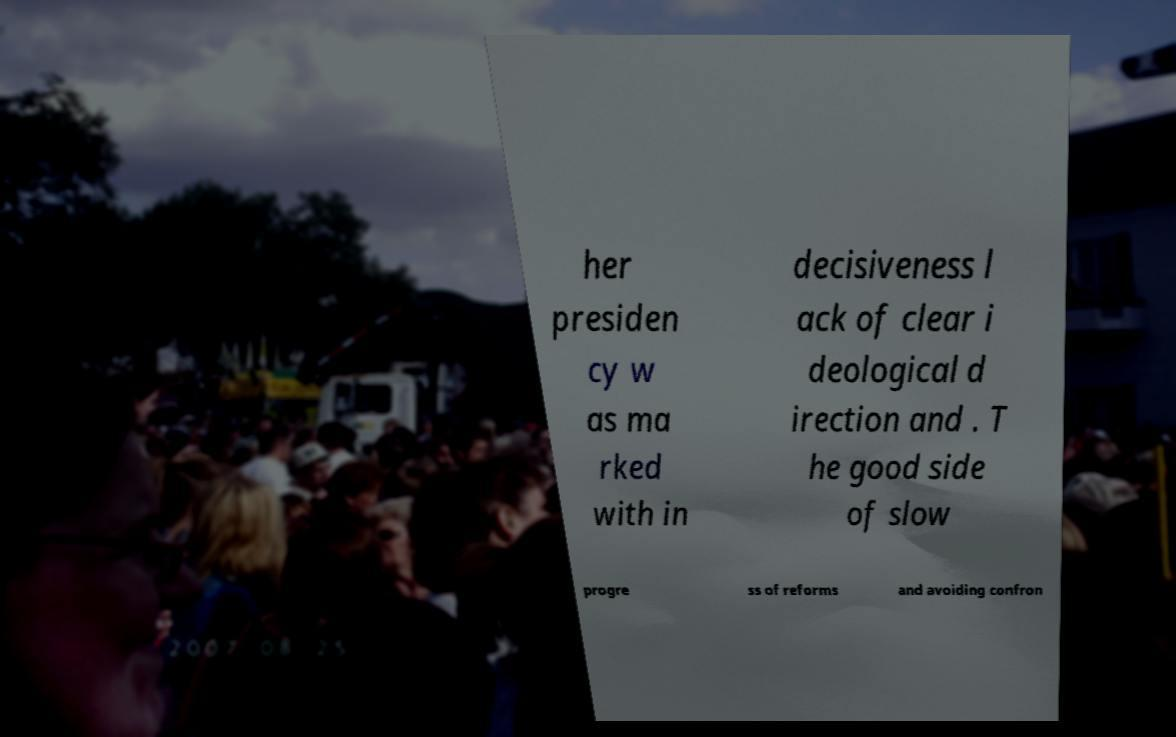Could you extract and type out the text from this image? her presiden cy w as ma rked with in decisiveness l ack of clear i deological d irection and . T he good side of slow progre ss of reforms and avoiding confron 